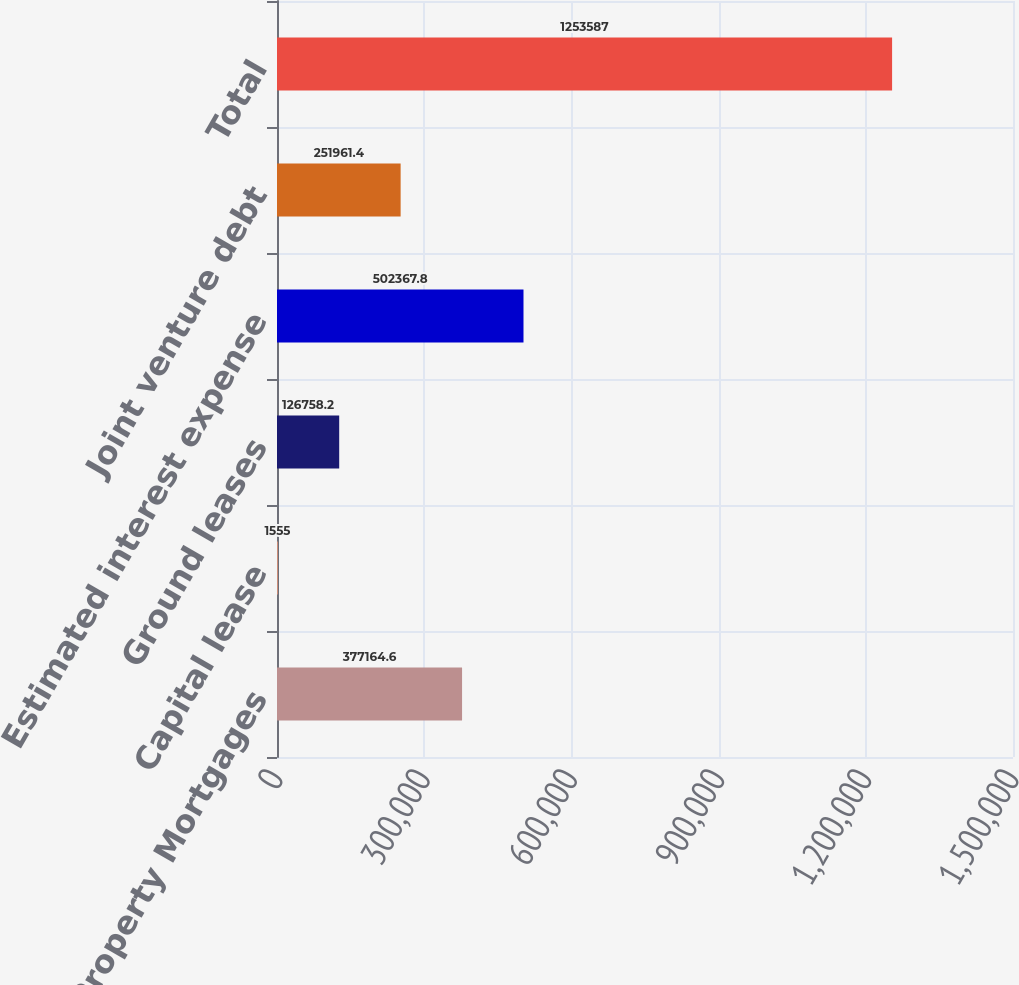Convert chart to OTSL. <chart><loc_0><loc_0><loc_500><loc_500><bar_chart><fcel>Property Mortgages<fcel>Capital lease<fcel>Ground leases<fcel>Estimated interest expense<fcel>Joint venture debt<fcel>Total<nl><fcel>377165<fcel>1555<fcel>126758<fcel>502368<fcel>251961<fcel>1.25359e+06<nl></chart> 